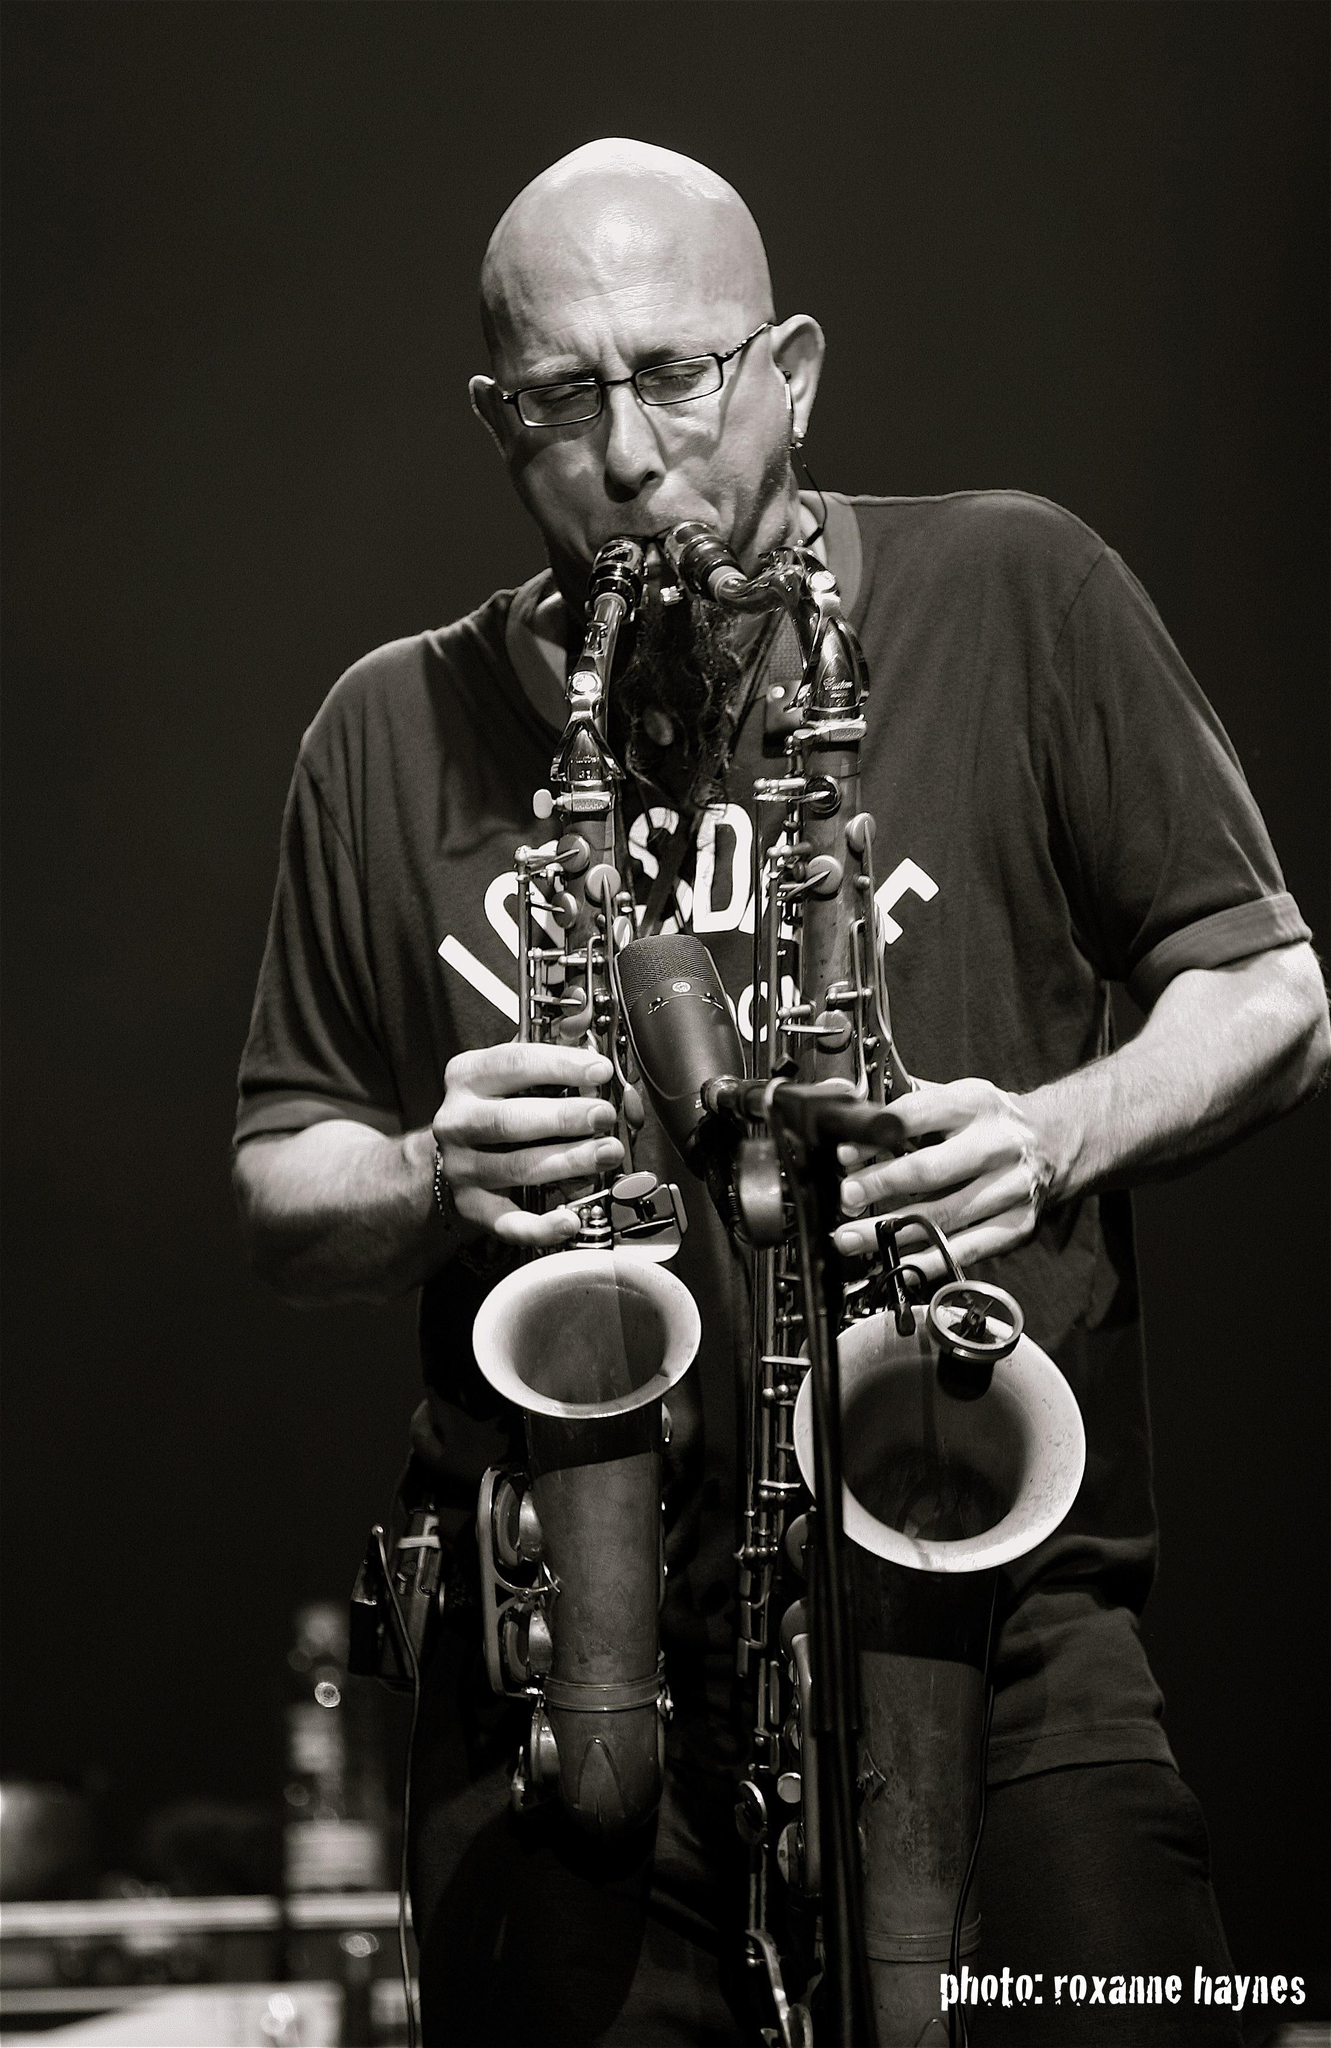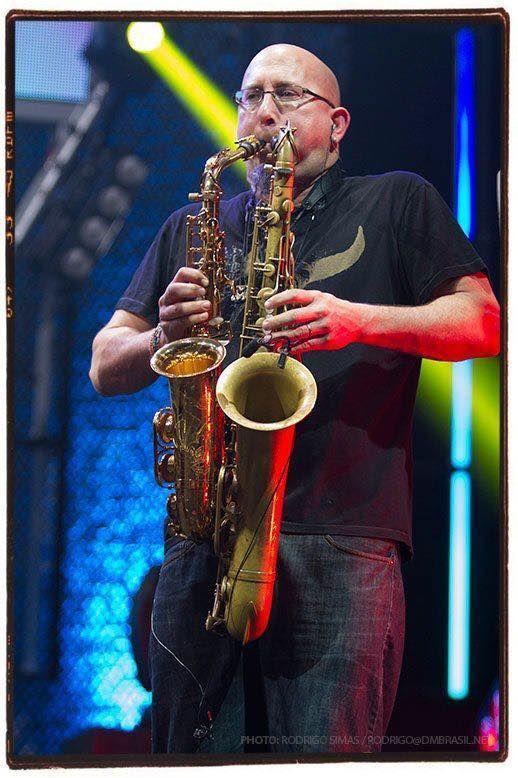The first image is the image on the left, the second image is the image on the right. Assess this claim about the two images: "The musician in the image on the left is playing two saxes.". Correct or not? Answer yes or no. Yes. The first image is the image on the left, the second image is the image on the right. Analyze the images presented: Is the assertion "Left image shows a man simultaneously playing two brass instruments, and the right image does not." valid? Answer yes or no. No. 